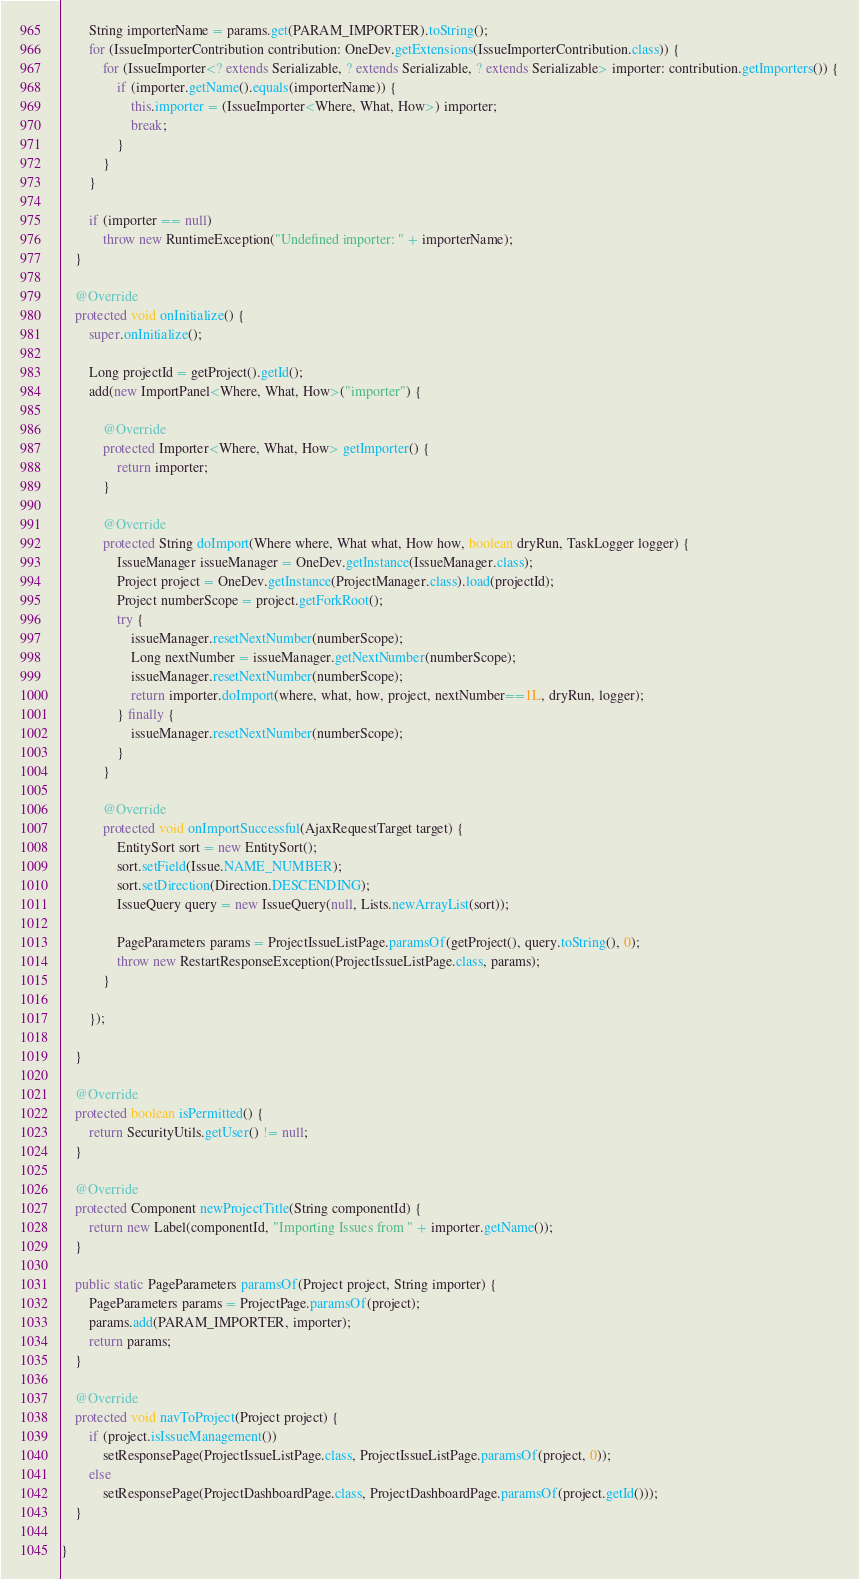<code> <loc_0><loc_0><loc_500><loc_500><_Java_>		String importerName = params.get(PARAM_IMPORTER).toString();
		for (IssueImporterContribution contribution: OneDev.getExtensions(IssueImporterContribution.class)) {
			for (IssueImporter<? extends Serializable, ? extends Serializable, ? extends Serializable> importer: contribution.getImporters()) {
				if (importer.getName().equals(importerName)) {
					this.importer = (IssueImporter<Where, What, How>) importer;
					break;
				}
			}
		}
		
		if (importer == null)
			throw new RuntimeException("Undefined importer: " + importerName);
	}

	@Override
	protected void onInitialize() {
		super.onInitialize();

		Long projectId = getProject().getId();
		add(new ImportPanel<Where, What, How>("importer") {

			@Override
			protected Importer<Where, What, How> getImporter() {
				return importer;
			}

			@Override
			protected String doImport(Where where, What what, How how, boolean dryRun, TaskLogger logger) {
				IssueManager issueManager = OneDev.getInstance(IssueManager.class);
				Project project = OneDev.getInstance(ProjectManager.class).load(projectId);
				Project numberScope = project.getForkRoot();
				try {
					issueManager.resetNextNumber(numberScope);
					Long nextNumber = issueManager.getNextNumber(numberScope);
					issueManager.resetNextNumber(numberScope);
					return importer.doImport(where, what, how, project, nextNumber==1L, dryRun, logger);
				} finally {
					issueManager.resetNextNumber(numberScope);
				}
			}

			@Override
			protected void onImportSuccessful(AjaxRequestTarget target) {
				EntitySort sort = new EntitySort();
				sort.setField(Issue.NAME_NUMBER);
				sort.setDirection(Direction.DESCENDING);
				IssueQuery query = new IssueQuery(null, Lists.newArrayList(sort));
				
				PageParameters params = ProjectIssueListPage.paramsOf(getProject(), query.toString(), 0);
				throw new RestartResponseException(ProjectIssueListPage.class, params);
			}
			
		});
		
	}

	@Override
	protected boolean isPermitted() {
		return SecurityUtils.getUser() != null;
	}
	
	@Override
	protected Component newProjectTitle(String componentId) {
		return new Label(componentId, "Importing Issues from " + importer.getName());
	}
	
	public static PageParameters paramsOf(Project project, String importer) {
		PageParameters params = ProjectPage.paramsOf(project);
		params.add(PARAM_IMPORTER, importer);
		return params;
	}
	
	@Override
	protected void navToProject(Project project) {
		if (project.isIssueManagement()) 
			setResponsePage(ProjectIssueListPage.class, ProjectIssueListPage.paramsOf(project, 0));
		else
			setResponsePage(ProjectDashboardPage.class, ProjectDashboardPage.paramsOf(project.getId()));
	}
	
}
</code> 